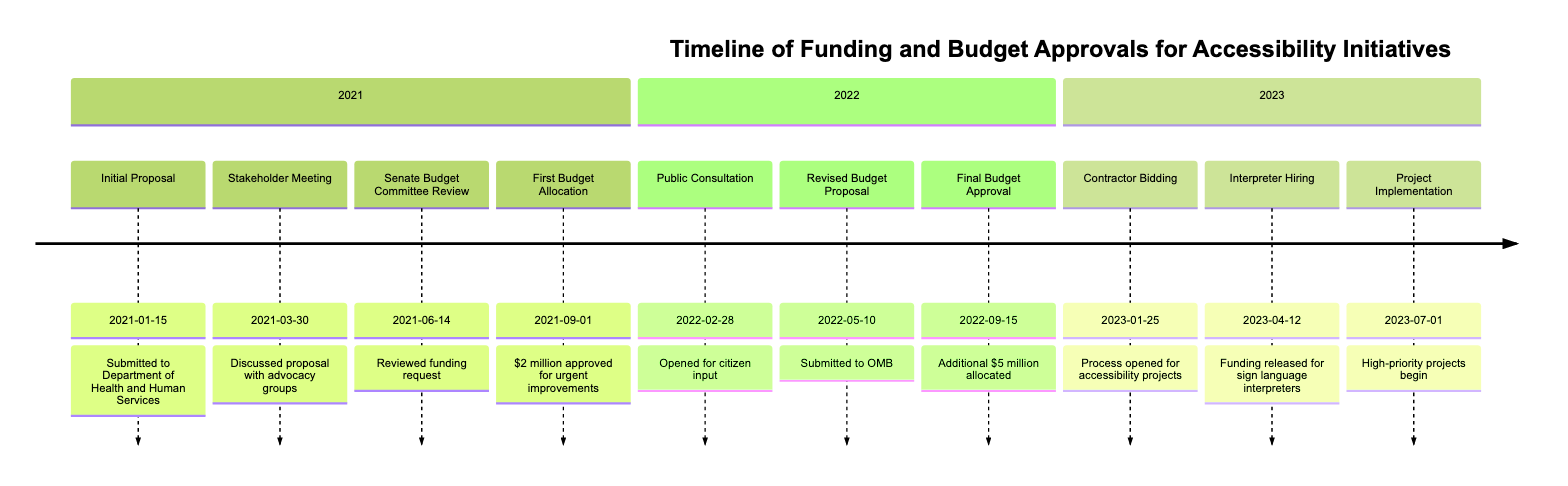What event was submitted on January 15, 2021? The event submitted on January 15, 2021, is the "Initial Proposal for Accessibility Initiatives," which outlines goals and budget requirements.
Answer: Initial Proposal for Accessibility Initiatives How much funding was approved on September 1, 2021? On September 1, 2021, the first budget allocation of $2 million was approved for urgent accessibility improvements.
Answer: $2 million What happened on May 10, 2022? On May 10, 2022, a "Revised Budget Proposal Submission" was made, incorporating feedback from the public and stakeholders.
Answer: Revised Budget Proposal Submission How many additional million dollars were allocated on September 15, 2022? On September 15, 2022, an additional $5 million was allocated for extensive accessibility upgrades as part of the final budget approval.
Answer: $5 million Which event marks the start of project implementation in 2023? The event that marks the start of project implementation in 2023 is the "Project Implementation Start" on July 1.
Answer: Project Implementation Start What is the significance of April 12, 2023, in the timeline? April 12, 2023, is significant because funding was released for hiring additional sign language interpreters, enhancing communication accessibility.
Answer: Funding released for hiring sign language interpreters How many total events are recorded in this timeline? There are a total of 10 events recorded in this timeline, spanning from 2021 to 2023.
Answer: 10 events Identify the first event that involved public input. The first event involving public input is the "Public Consultation Period," which opened on February 28, 2022, allowing citizen feedback.
Answer: Public Consultation Period What was the purpose of the March 30, 2021, meeting? The purpose of the meeting on March 30, 2021, was to discuss the proposal with key stakeholders and receive feedback, particularly from disability advocacy groups.
Answer: Discussed proposal with advocacy groups What type of project is targeted by the bids opened on January 25, 2023? The bids opened on January 25, 2023, are targeted for accessibility projects, which include improvements such as elevators and ramps.
Answer: Accessibility projects 